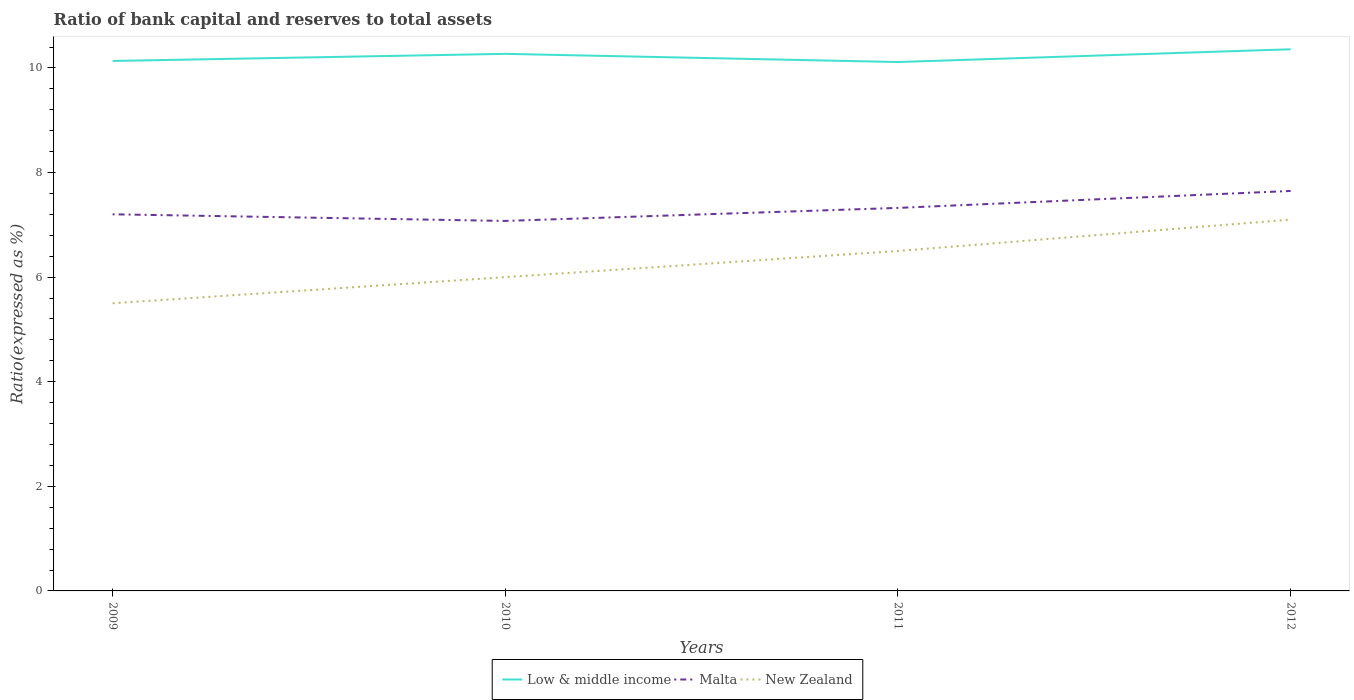How many different coloured lines are there?
Ensure brevity in your answer.  3. Does the line corresponding to Low & middle income intersect with the line corresponding to Malta?
Your answer should be compact. No. Is the number of lines equal to the number of legend labels?
Provide a short and direct response. Yes. Across all years, what is the maximum ratio of bank capital and reserves to total assets in New Zealand?
Your response must be concise. 5.5. What is the total ratio of bank capital and reserves to total assets in New Zealand in the graph?
Offer a very short reply. -1.6. What is the difference between the highest and the second highest ratio of bank capital and reserves to total assets in Low & middle income?
Provide a succinct answer. 0.24. What is the difference between the highest and the lowest ratio of bank capital and reserves to total assets in Malta?
Offer a very short reply. 2. How many years are there in the graph?
Keep it short and to the point. 4. Are the values on the major ticks of Y-axis written in scientific E-notation?
Offer a very short reply. No. Does the graph contain any zero values?
Ensure brevity in your answer.  No. What is the title of the graph?
Give a very brief answer. Ratio of bank capital and reserves to total assets. What is the label or title of the X-axis?
Ensure brevity in your answer.  Years. What is the label or title of the Y-axis?
Ensure brevity in your answer.  Ratio(expressed as %). What is the Ratio(expressed as %) of Low & middle income in 2009?
Keep it short and to the point. 10.13. What is the Ratio(expressed as %) in Malta in 2009?
Give a very brief answer. 7.2. What is the Ratio(expressed as %) in New Zealand in 2009?
Your response must be concise. 5.5. What is the Ratio(expressed as %) of Low & middle income in 2010?
Keep it short and to the point. 10.27. What is the Ratio(expressed as %) of Malta in 2010?
Your answer should be compact. 7.07. What is the Ratio(expressed as %) in New Zealand in 2010?
Make the answer very short. 6. What is the Ratio(expressed as %) in Low & middle income in 2011?
Provide a short and direct response. 10.11. What is the Ratio(expressed as %) in Malta in 2011?
Keep it short and to the point. 7.32. What is the Ratio(expressed as %) in New Zealand in 2011?
Make the answer very short. 6.5. What is the Ratio(expressed as %) of Low & middle income in 2012?
Offer a very short reply. 10.36. What is the Ratio(expressed as %) of Malta in 2012?
Your answer should be very brief. 7.65. Across all years, what is the maximum Ratio(expressed as %) of Low & middle income?
Offer a terse response. 10.36. Across all years, what is the maximum Ratio(expressed as %) of Malta?
Provide a succinct answer. 7.65. Across all years, what is the maximum Ratio(expressed as %) in New Zealand?
Your answer should be very brief. 7.1. Across all years, what is the minimum Ratio(expressed as %) in Low & middle income?
Provide a succinct answer. 10.11. Across all years, what is the minimum Ratio(expressed as %) of Malta?
Provide a succinct answer. 7.07. Across all years, what is the minimum Ratio(expressed as %) of New Zealand?
Ensure brevity in your answer.  5.5. What is the total Ratio(expressed as %) in Low & middle income in the graph?
Provide a short and direct response. 40.87. What is the total Ratio(expressed as %) of Malta in the graph?
Offer a terse response. 29.25. What is the total Ratio(expressed as %) of New Zealand in the graph?
Provide a succinct answer. 25.1. What is the difference between the Ratio(expressed as %) of Low & middle income in 2009 and that in 2010?
Offer a terse response. -0.14. What is the difference between the Ratio(expressed as %) of Malta in 2009 and that in 2010?
Your response must be concise. 0.13. What is the difference between the Ratio(expressed as %) of Low & middle income in 2009 and that in 2011?
Give a very brief answer. 0.02. What is the difference between the Ratio(expressed as %) of Malta in 2009 and that in 2011?
Make the answer very short. -0.12. What is the difference between the Ratio(expressed as %) in Low & middle income in 2009 and that in 2012?
Provide a short and direct response. -0.22. What is the difference between the Ratio(expressed as %) of Malta in 2009 and that in 2012?
Provide a short and direct response. -0.45. What is the difference between the Ratio(expressed as %) of New Zealand in 2009 and that in 2012?
Offer a terse response. -1.6. What is the difference between the Ratio(expressed as %) in Low & middle income in 2010 and that in 2011?
Provide a short and direct response. 0.16. What is the difference between the Ratio(expressed as %) in Malta in 2010 and that in 2011?
Offer a very short reply. -0.25. What is the difference between the Ratio(expressed as %) in Low & middle income in 2010 and that in 2012?
Make the answer very short. -0.09. What is the difference between the Ratio(expressed as %) in Malta in 2010 and that in 2012?
Give a very brief answer. -0.57. What is the difference between the Ratio(expressed as %) of New Zealand in 2010 and that in 2012?
Offer a terse response. -1.1. What is the difference between the Ratio(expressed as %) of Low & middle income in 2011 and that in 2012?
Offer a very short reply. -0.24. What is the difference between the Ratio(expressed as %) of Malta in 2011 and that in 2012?
Provide a succinct answer. -0.32. What is the difference between the Ratio(expressed as %) of New Zealand in 2011 and that in 2012?
Provide a succinct answer. -0.6. What is the difference between the Ratio(expressed as %) in Low & middle income in 2009 and the Ratio(expressed as %) in Malta in 2010?
Make the answer very short. 3.06. What is the difference between the Ratio(expressed as %) in Low & middle income in 2009 and the Ratio(expressed as %) in New Zealand in 2010?
Your answer should be compact. 4.13. What is the difference between the Ratio(expressed as %) of Malta in 2009 and the Ratio(expressed as %) of New Zealand in 2010?
Your answer should be very brief. 1.2. What is the difference between the Ratio(expressed as %) in Low & middle income in 2009 and the Ratio(expressed as %) in Malta in 2011?
Provide a succinct answer. 2.81. What is the difference between the Ratio(expressed as %) of Low & middle income in 2009 and the Ratio(expressed as %) of New Zealand in 2011?
Provide a succinct answer. 3.63. What is the difference between the Ratio(expressed as %) of Malta in 2009 and the Ratio(expressed as %) of New Zealand in 2011?
Your answer should be compact. 0.7. What is the difference between the Ratio(expressed as %) of Low & middle income in 2009 and the Ratio(expressed as %) of Malta in 2012?
Your response must be concise. 2.49. What is the difference between the Ratio(expressed as %) in Low & middle income in 2009 and the Ratio(expressed as %) in New Zealand in 2012?
Keep it short and to the point. 3.03. What is the difference between the Ratio(expressed as %) in Malta in 2009 and the Ratio(expressed as %) in New Zealand in 2012?
Make the answer very short. 0.1. What is the difference between the Ratio(expressed as %) in Low & middle income in 2010 and the Ratio(expressed as %) in Malta in 2011?
Provide a succinct answer. 2.95. What is the difference between the Ratio(expressed as %) in Low & middle income in 2010 and the Ratio(expressed as %) in New Zealand in 2011?
Ensure brevity in your answer.  3.77. What is the difference between the Ratio(expressed as %) in Malta in 2010 and the Ratio(expressed as %) in New Zealand in 2011?
Offer a terse response. 0.57. What is the difference between the Ratio(expressed as %) in Low & middle income in 2010 and the Ratio(expressed as %) in Malta in 2012?
Ensure brevity in your answer.  2.62. What is the difference between the Ratio(expressed as %) of Low & middle income in 2010 and the Ratio(expressed as %) of New Zealand in 2012?
Make the answer very short. 3.17. What is the difference between the Ratio(expressed as %) in Malta in 2010 and the Ratio(expressed as %) in New Zealand in 2012?
Your answer should be very brief. -0.03. What is the difference between the Ratio(expressed as %) in Low & middle income in 2011 and the Ratio(expressed as %) in Malta in 2012?
Keep it short and to the point. 2.47. What is the difference between the Ratio(expressed as %) of Low & middle income in 2011 and the Ratio(expressed as %) of New Zealand in 2012?
Your answer should be very brief. 3.01. What is the difference between the Ratio(expressed as %) in Malta in 2011 and the Ratio(expressed as %) in New Zealand in 2012?
Keep it short and to the point. 0.22. What is the average Ratio(expressed as %) in Low & middle income per year?
Offer a terse response. 10.22. What is the average Ratio(expressed as %) of Malta per year?
Give a very brief answer. 7.31. What is the average Ratio(expressed as %) in New Zealand per year?
Your answer should be compact. 6.28. In the year 2009, what is the difference between the Ratio(expressed as %) in Low & middle income and Ratio(expressed as %) in Malta?
Offer a terse response. 2.93. In the year 2009, what is the difference between the Ratio(expressed as %) of Low & middle income and Ratio(expressed as %) of New Zealand?
Your response must be concise. 4.63. In the year 2009, what is the difference between the Ratio(expressed as %) of Malta and Ratio(expressed as %) of New Zealand?
Make the answer very short. 1.7. In the year 2010, what is the difference between the Ratio(expressed as %) of Low & middle income and Ratio(expressed as %) of Malta?
Give a very brief answer. 3.19. In the year 2010, what is the difference between the Ratio(expressed as %) of Low & middle income and Ratio(expressed as %) of New Zealand?
Make the answer very short. 4.27. In the year 2010, what is the difference between the Ratio(expressed as %) of Malta and Ratio(expressed as %) of New Zealand?
Your answer should be compact. 1.07. In the year 2011, what is the difference between the Ratio(expressed as %) of Low & middle income and Ratio(expressed as %) of Malta?
Your answer should be very brief. 2.79. In the year 2011, what is the difference between the Ratio(expressed as %) in Low & middle income and Ratio(expressed as %) in New Zealand?
Your response must be concise. 3.61. In the year 2011, what is the difference between the Ratio(expressed as %) in Malta and Ratio(expressed as %) in New Zealand?
Provide a succinct answer. 0.82. In the year 2012, what is the difference between the Ratio(expressed as %) in Low & middle income and Ratio(expressed as %) in Malta?
Give a very brief answer. 2.71. In the year 2012, what is the difference between the Ratio(expressed as %) in Low & middle income and Ratio(expressed as %) in New Zealand?
Provide a succinct answer. 3.26. In the year 2012, what is the difference between the Ratio(expressed as %) of Malta and Ratio(expressed as %) of New Zealand?
Offer a very short reply. 0.55. What is the ratio of the Ratio(expressed as %) in Malta in 2009 to that in 2010?
Ensure brevity in your answer.  1.02. What is the ratio of the Ratio(expressed as %) in Malta in 2009 to that in 2011?
Your answer should be very brief. 0.98. What is the ratio of the Ratio(expressed as %) of New Zealand in 2009 to that in 2011?
Give a very brief answer. 0.85. What is the ratio of the Ratio(expressed as %) of Low & middle income in 2009 to that in 2012?
Keep it short and to the point. 0.98. What is the ratio of the Ratio(expressed as %) of Malta in 2009 to that in 2012?
Provide a short and direct response. 0.94. What is the ratio of the Ratio(expressed as %) of New Zealand in 2009 to that in 2012?
Provide a succinct answer. 0.77. What is the ratio of the Ratio(expressed as %) in Low & middle income in 2010 to that in 2011?
Provide a short and direct response. 1.02. What is the ratio of the Ratio(expressed as %) in New Zealand in 2010 to that in 2011?
Give a very brief answer. 0.92. What is the ratio of the Ratio(expressed as %) in Low & middle income in 2010 to that in 2012?
Provide a short and direct response. 0.99. What is the ratio of the Ratio(expressed as %) in Malta in 2010 to that in 2012?
Provide a short and direct response. 0.93. What is the ratio of the Ratio(expressed as %) in New Zealand in 2010 to that in 2012?
Make the answer very short. 0.85. What is the ratio of the Ratio(expressed as %) of Low & middle income in 2011 to that in 2012?
Your response must be concise. 0.98. What is the ratio of the Ratio(expressed as %) of Malta in 2011 to that in 2012?
Ensure brevity in your answer.  0.96. What is the ratio of the Ratio(expressed as %) of New Zealand in 2011 to that in 2012?
Ensure brevity in your answer.  0.92. What is the difference between the highest and the second highest Ratio(expressed as %) in Low & middle income?
Provide a short and direct response. 0.09. What is the difference between the highest and the second highest Ratio(expressed as %) of Malta?
Your answer should be compact. 0.32. What is the difference between the highest and the second highest Ratio(expressed as %) of New Zealand?
Provide a succinct answer. 0.6. What is the difference between the highest and the lowest Ratio(expressed as %) in Low & middle income?
Your answer should be very brief. 0.24. What is the difference between the highest and the lowest Ratio(expressed as %) in Malta?
Keep it short and to the point. 0.57. 